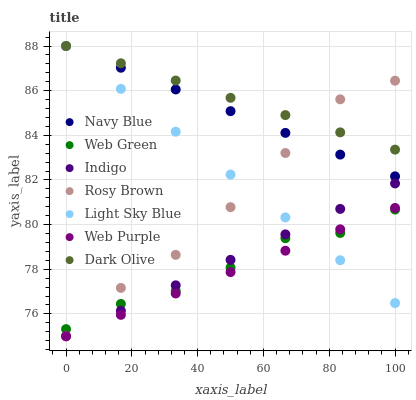Does Web Purple have the minimum area under the curve?
Answer yes or no. Yes. Does Dark Olive have the maximum area under the curve?
Answer yes or no. Yes. Does Indigo have the minimum area under the curve?
Answer yes or no. No. Does Indigo have the maximum area under the curve?
Answer yes or no. No. Is Web Purple the smoothest?
Answer yes or no. Yes. Is Rosy Brown the roughest?
Answer yes or no. Yes. Is Indigo the smoothest?
Answer yes or no. No. Is Indigo the roughest?
Answer yes or no. No. Does Indigo have the lowest value?
Answer yes or no. Yes. Does Navy Blue have the lowest value?
Answer yes or no. No. Does Light Sky Blue have the highest value?
Answer yes or no. Yes. Does Indigo have the highest value?
Answer yes or no. No. Is Web Purple less than Navy Blue?
Answer yes or no. Yes. Is Dark Olive greater than Web Green?
Answer yes or no. Yes. Does Indigo intersect Rosy Brown?
Answer yes or no. Yes. Is Indigo less than Rosy Brown?
Answer yes or no. No. Is Indigo greater than Rosy Brown?
Answer yes or no. No. Does Web Purple intersect Navy Blue?
Answer yes or no. No. 